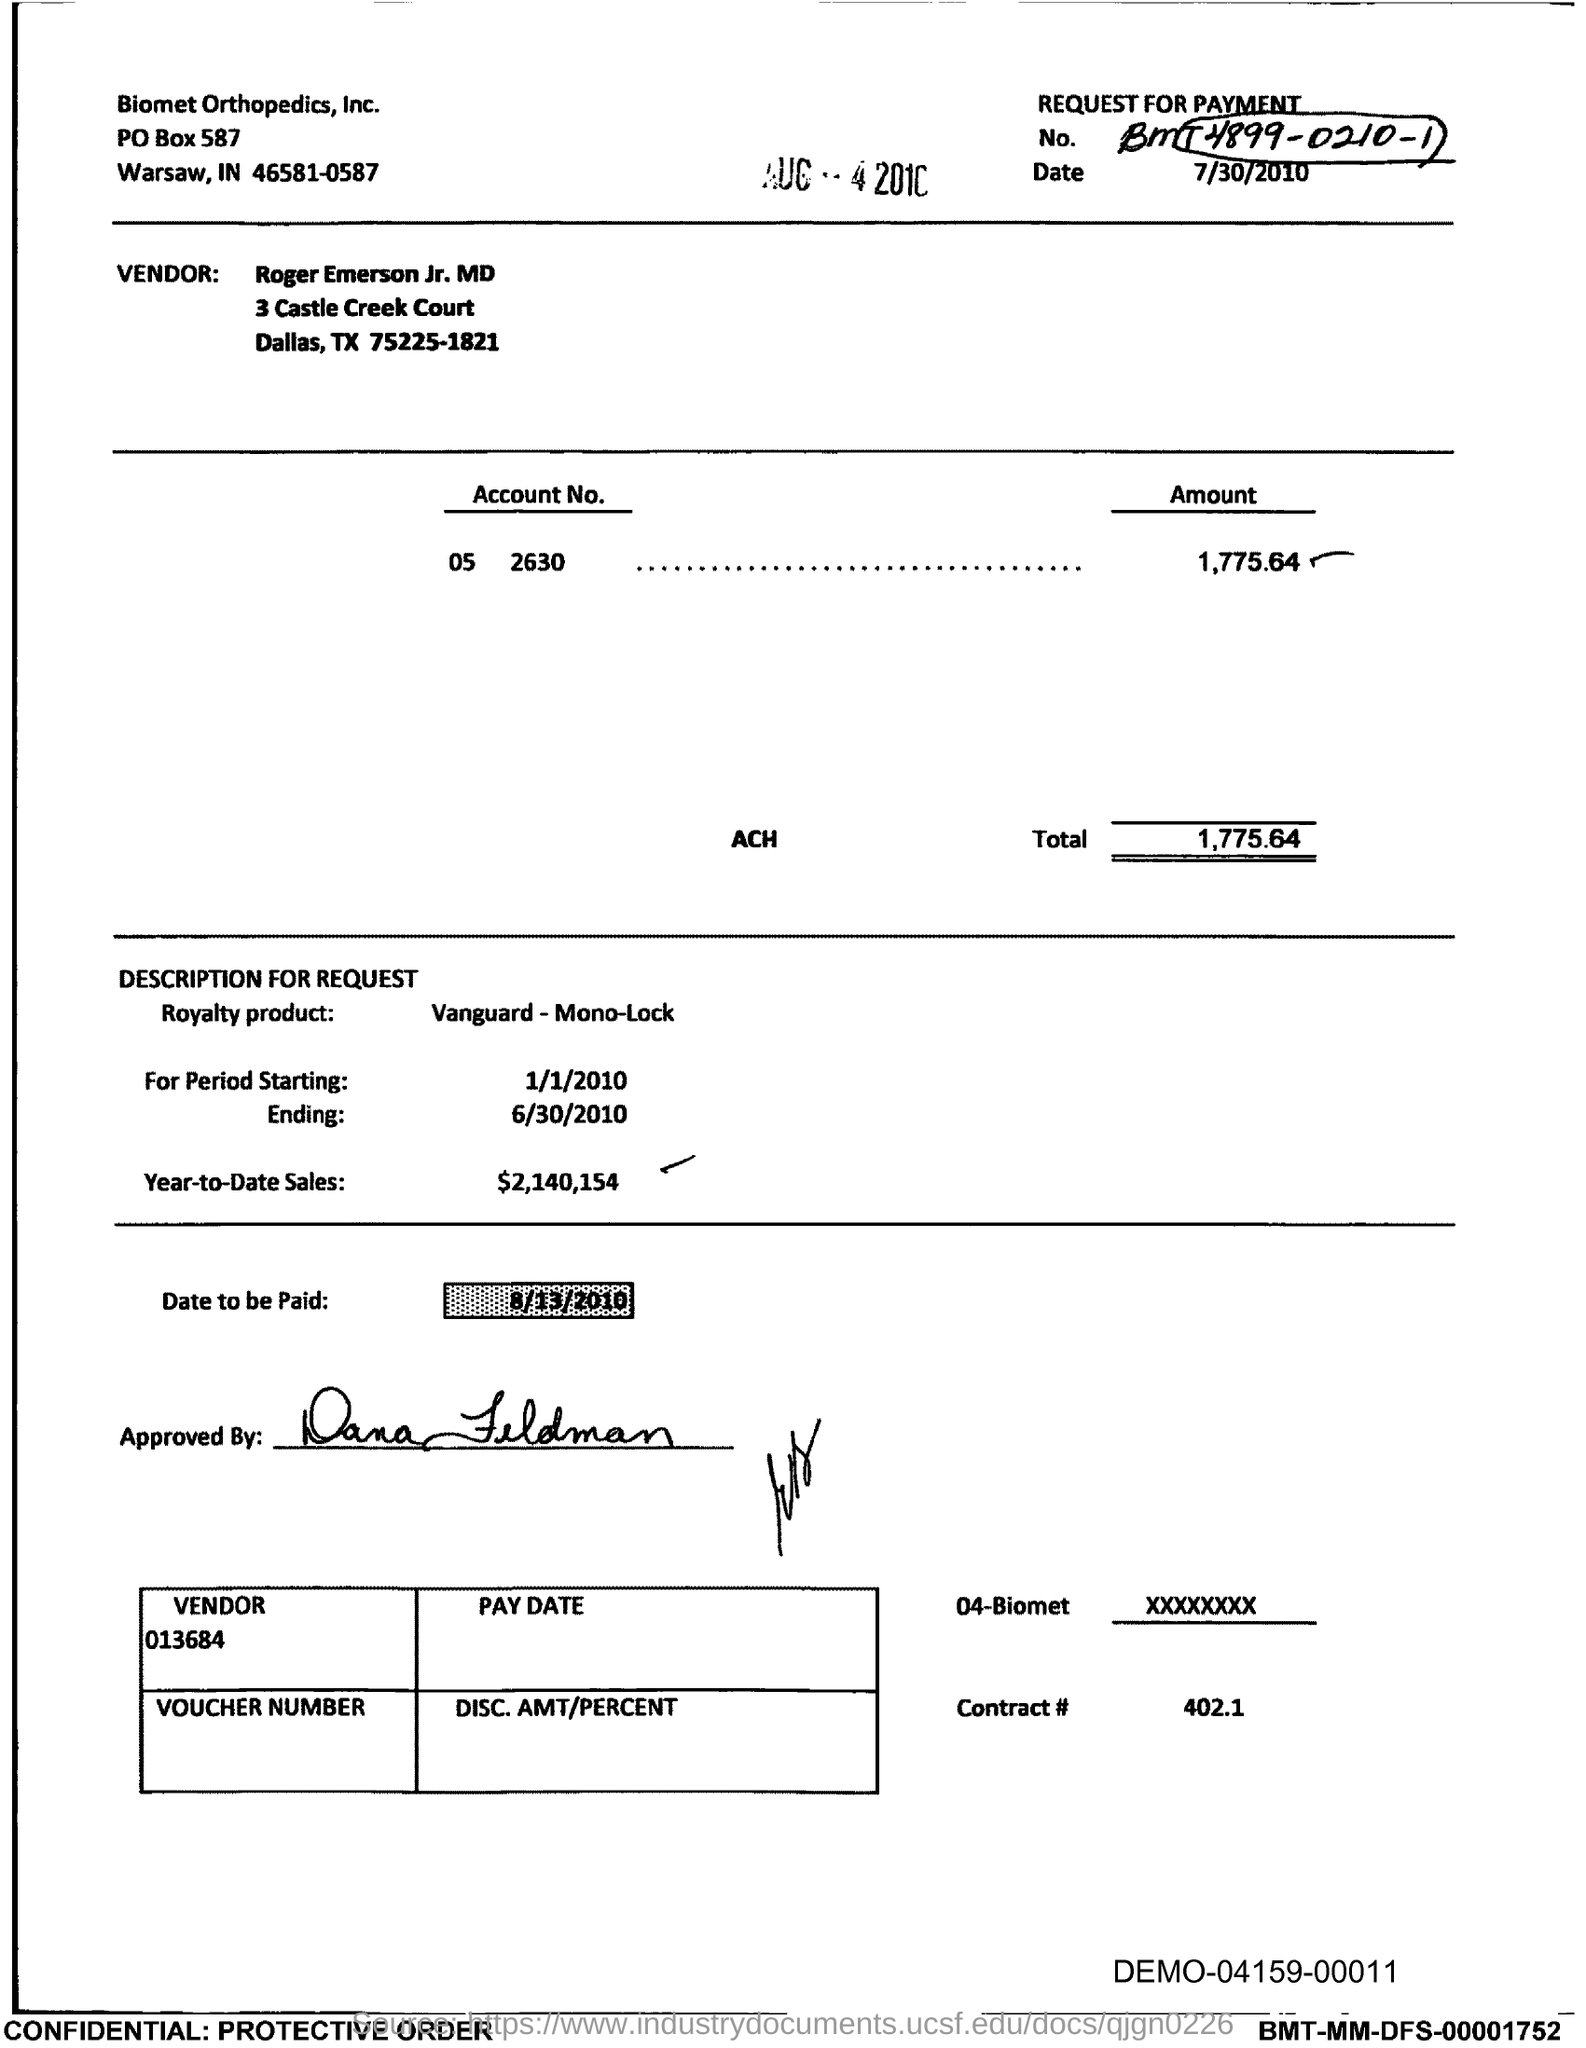What is the date to be paid mentioned in the document?
Offer a terse response. 8/13/2010. What is the Total?
Give a very brief answer. 1,775.64. What is the Year-to-Date-Sales mentioned in the document?
Offer a terse response. 2,140,154. 